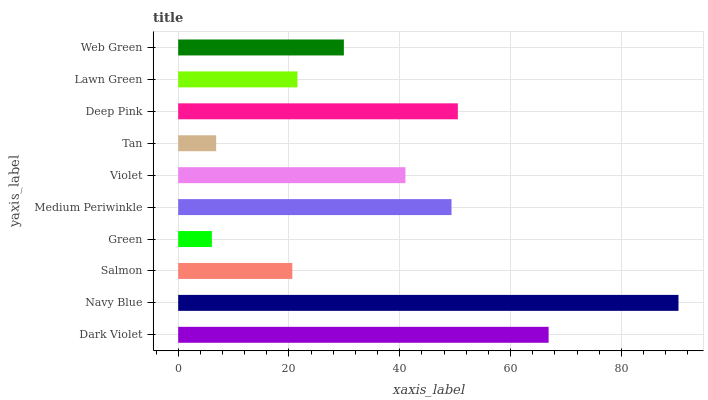Is Green the minimum?
Answer yes or no. Yes. Is Navy Blue the maximum?
Answer yes or no. Yes. Is Salmon the minimum?
Answer yes or no. No. Is Salmon the maximum?
Answer yes or no. No. Is Navy Blue greater than Salmon?
Answer yes or no. Yes. Is Salmon less than Navy Blue?
Answer yes or no. Yes. Is Salmon greater than Navy Blue?
Answer yes or no. No. Is Navy Blue less than Salmon?
Answer yes or no. No. Is Violet the high median?
Answer yes or no. Yes. Is Web Green the low median?
Answer yes or no. Yes. Is Dark Violet the high median?
Answer yes or no. No. Is Deep Pink the low median?
Answer yes or no. No. 